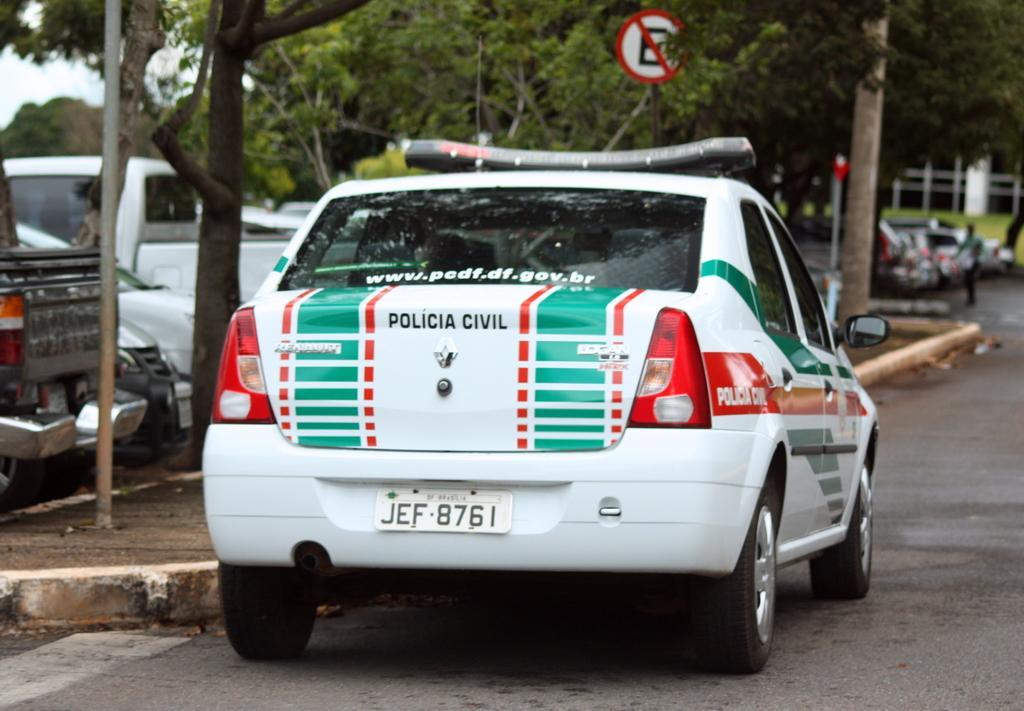Describe this image in one or two sentences. In this image, there are vehicles on the road. On the right side of the image, I can see a person standing. On the left side of the image, there is a pole. In the background, there are trees and the sky. At the top of the image, I can see a sign board to a pole. 